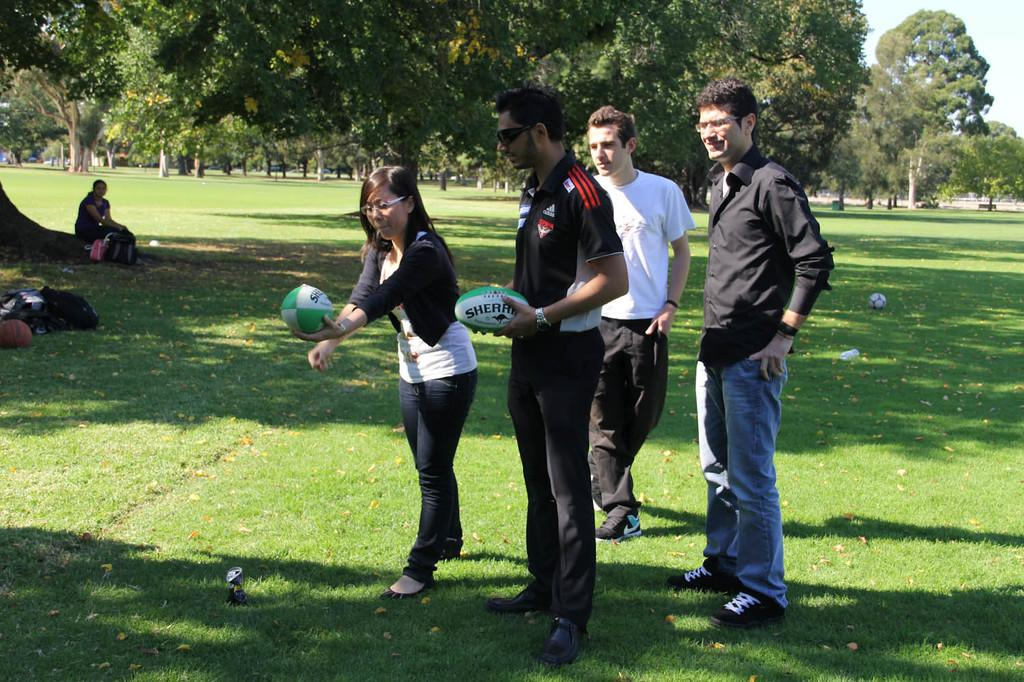Who or what is present in the image? There are people in the image. What can be seen on the ground in the image? The ground is visible in the image, and it has grass, leaves, and objects. What type of natural elements are present in the image? There are trees in the image. What part of the natural environment is visible in the image? The sky is visible in the image. What type of friction can be observed between the people and the grass in the image? There is no specific friction mentioned or observable between the people and the grass in the image. 